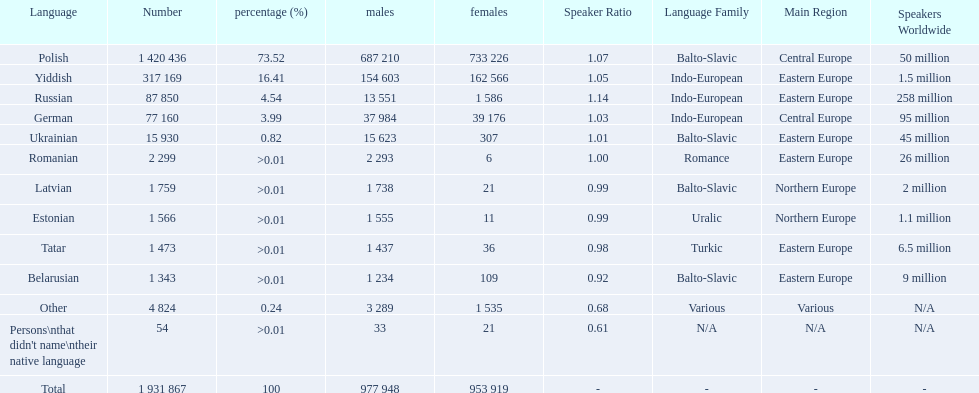What is the percentage of polish speakers? 73.52. What is the next highest percentage of speakers? 16.41. What language is this percentage? Yiddish. 